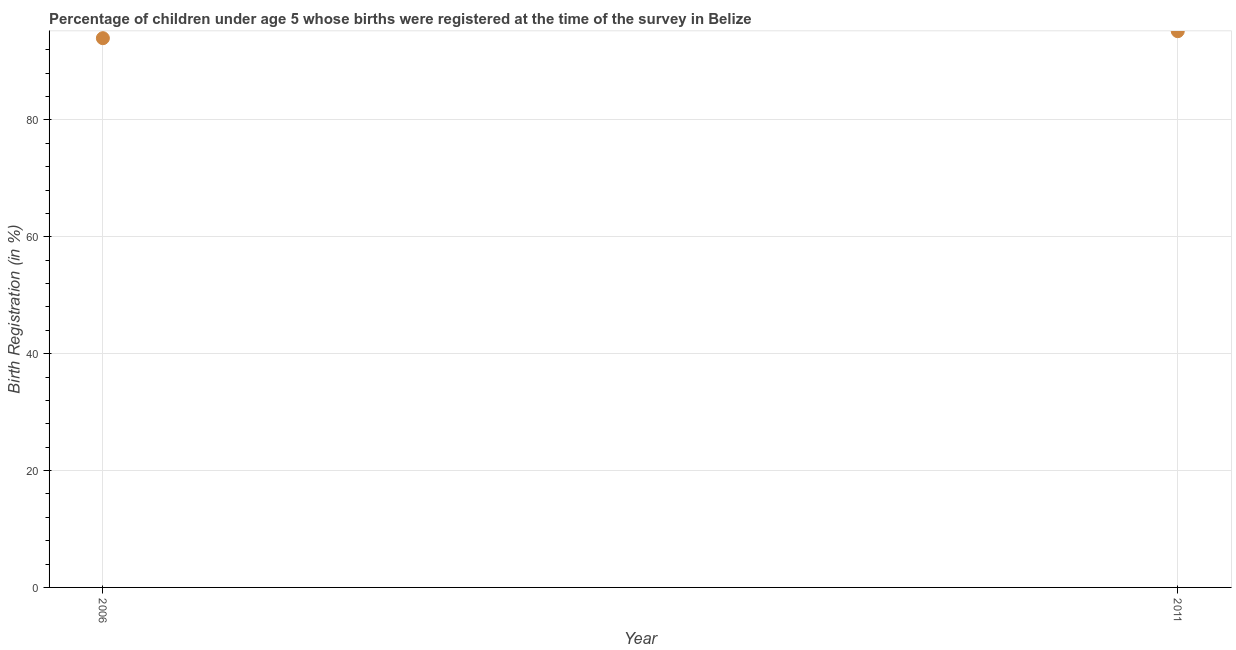What is the birth registration in 2006?
Provide a short and direct response. 94. Across all years, what is the maximum birth registration?
Provide a short and direct response. 95.2. Across all years, what is the minimum birth registration?
Offer a terse response. 94. In which year was the birth registration maximum?
Keep it short and to the point. 2011. What is the sum of the birth registration?
Offer a terse response. 189.2. What is the difference between the birth registration in 2006 and 2011?
Provide a short and direct response. -1.2. What is the average birth registration per year?
Offer a terse response. 94.6. What is the median birth registration?
Give a very brief answer. 94.6. What is the ratio of the birth registration in 2006 to that in 2011?
Keep it short and to the point. 0.99. Does the birth registration monotonically increase over the years?
Provide a short and direct response. Yes. How many years are there in the graph?
Give a very brief answer. 2. Does the graph contain any zero values?
Make the answer very short. No. What is the title of the graph?
Your answer should be compact. Percentage of children under age 5 whose births were registered at the time of the survey in Belize. What is the label or title of the Y-axis?
Provide a short and direct response. Birth Registration (in %). What is the Birth Registration (in %) in 2006?
Offer a terse response. 94. What is the Birth Registration (in %) in 2011?
Provide a succinct answer. 95.2. 